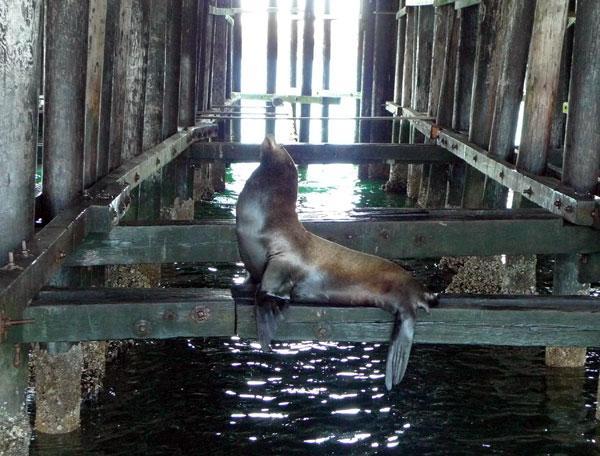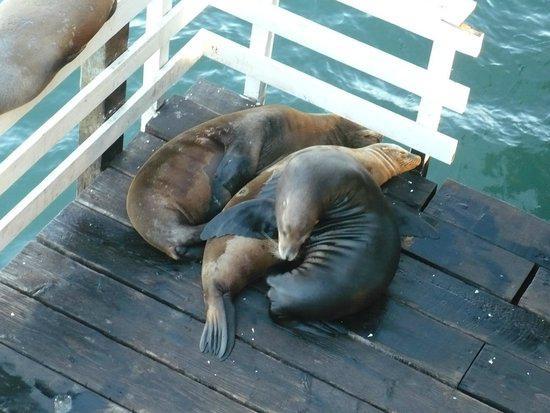The first image is the image on the left, the second image is the image on the right. For the images shown, is this caption "The left image shows at least one seal balanced on a cross beam near vertical poles in water beneath a pier." true? Answer yes or no. Yes. 